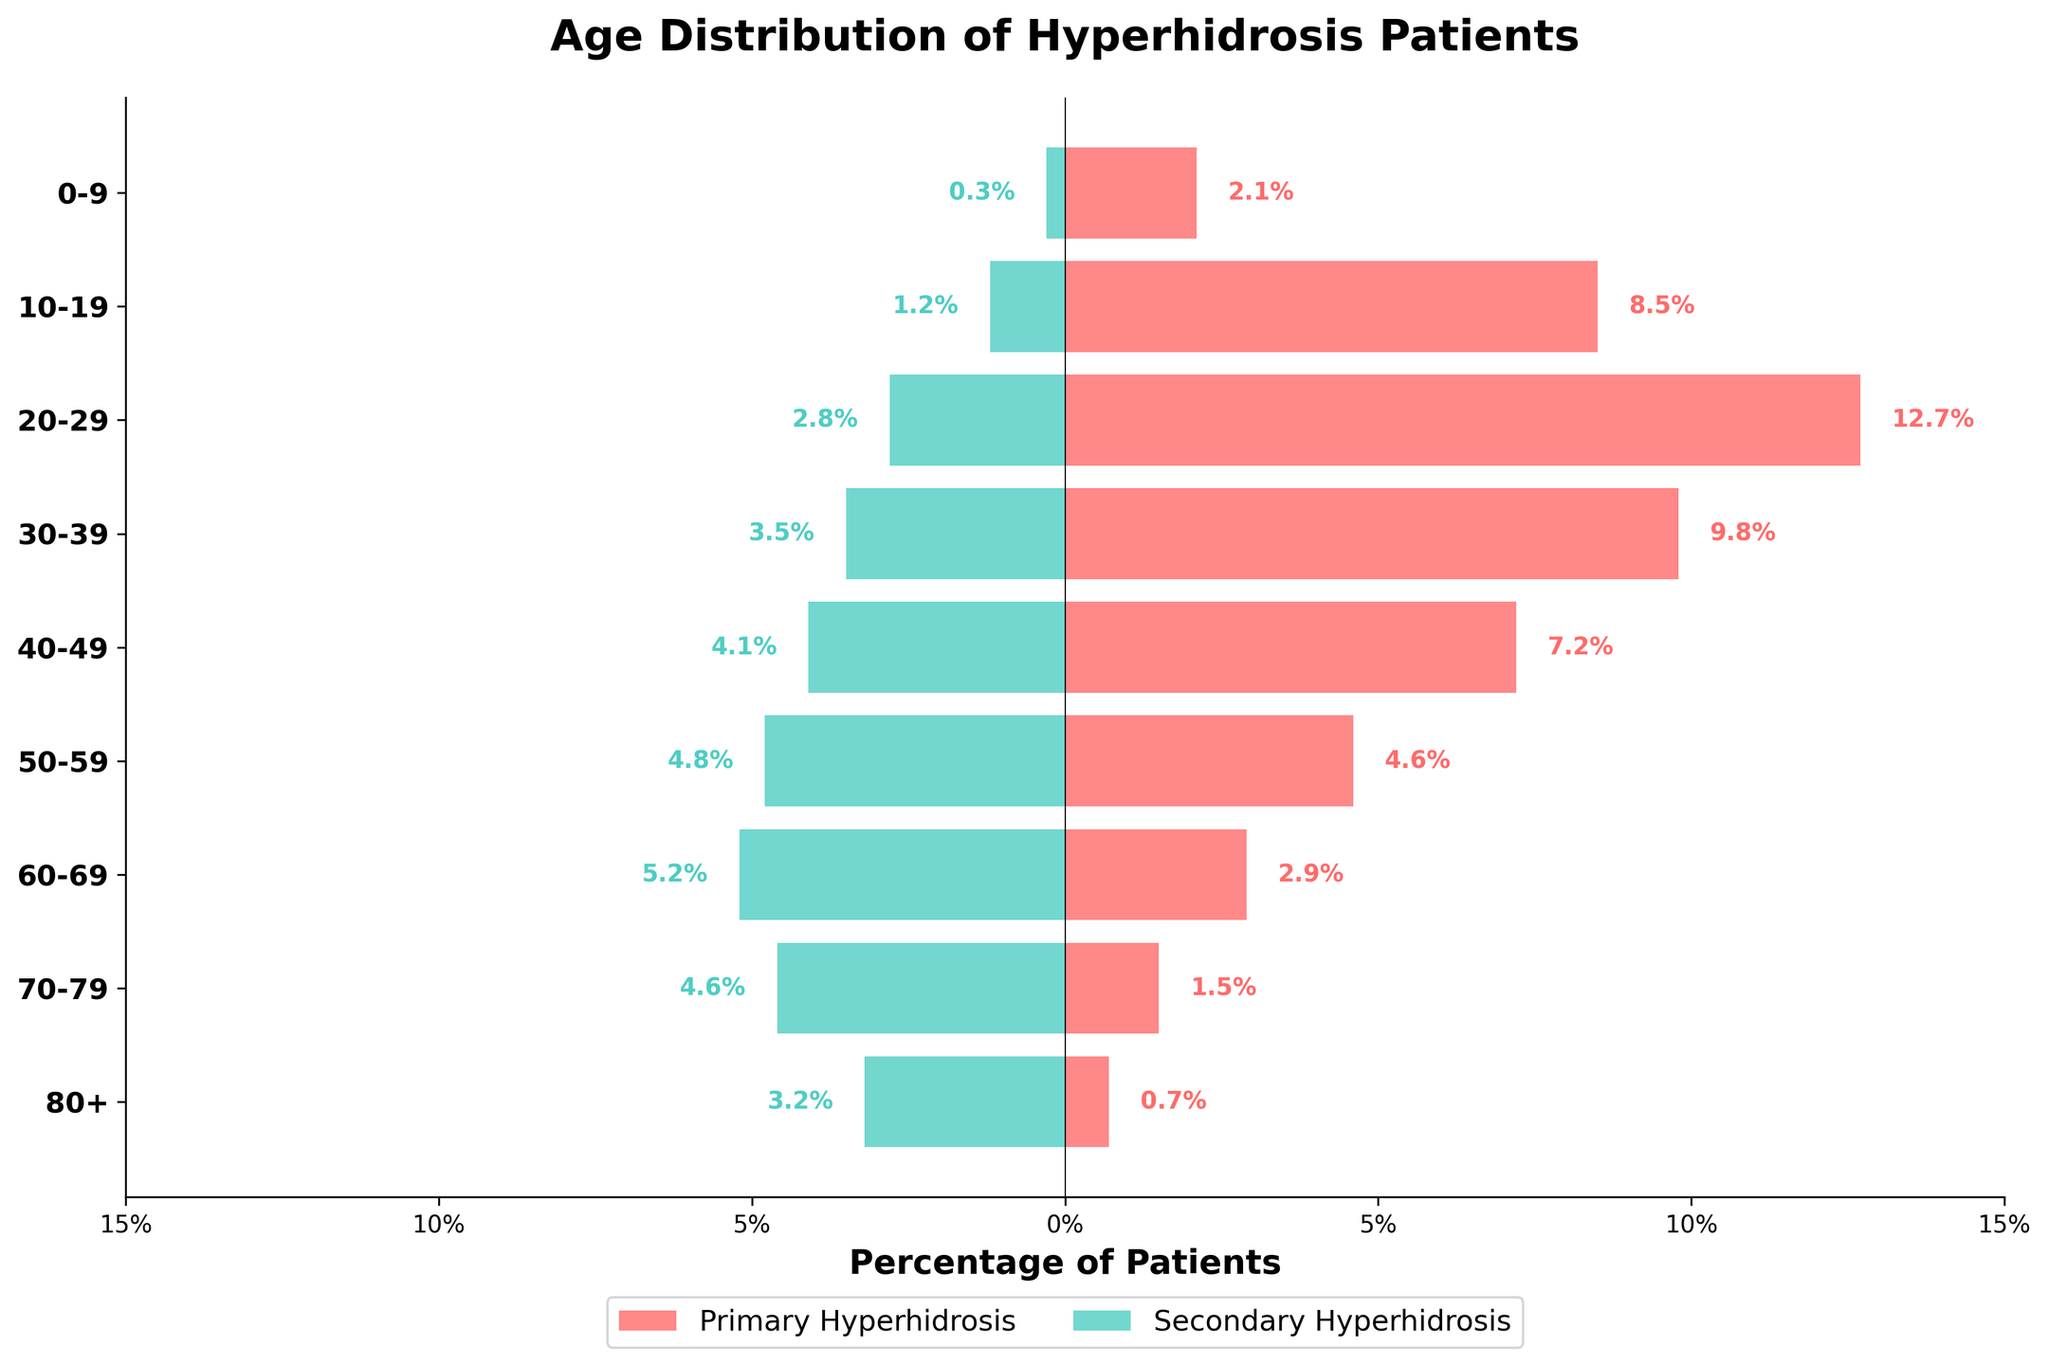What is the percentage of primary hyperhidrosis patients in the 20-29 age group? The primary hyperhidrosis percentage for the 20-29 age group is given as -12.7. The negative sign indicates that this is on the left side of the pyramid.
Answer: 12.7% Which age group has the highest percentage of secondary hyperhidrosis patients? Based on the bar lengths, the 60-69 age group has the longest bar on the right side, indicating the highest percentage of secondary hyperhidrosis patients.
Answer: 60-69 What is the total percentage of hyperhidrosis patients (primary and secondary) in the 40-49 age group? Add the percentages of primary (-7.2) and secondary (4.1) hyperhidrosis in the 40-49 age group: -7.2 + 4.1 = -3.1. In absolute terms, the total is 7.2 + 4.1 = 11.3%.
Answer: 11.3% In which age group is the gap between primary and secondary hyperhidrosis patients the smallest? The difference between the percentages of primary and secondary hyperhidrosis patients is closest in the 0-9 age group, where primary is -2.1% and secondary is 0.3%, giving a difference of 2.4%.
Answer: 0-9 Do any age groups have more secondary than primary hyperhidrosis patients? All age groups show longer red bars (primary) on the left than the green bars (secondary) on the right, indicating more primary hyperhidrosis patients in all age groups.
Answer: No Which age group has the lowest percentage of primary hyperhidrosis patients? The shortest red bar on the left represents the 80+ age group, indicating the lowest percentage of primary hyperhidrosis patients.
Answer: 80+ How many age groups have secondary hyperhidrosis percentages higher than 4%? Counting the bars on the right side that exceed 4% for secondary hyperhidrosis gives three age groups: 50-59, 60-69, and 70-79.
Answer: 3 What is the average percentage of primary hyperhidrosis patients across all age groups? Sum all percentages of primary hyperhidrosis and divide by the number of age groups: (-2.1 + -8.5 + -12.7 + -9.8 + -7.2 + -4.6 + -2.9 + -1.5 + -0.7) / 9 = -50.0 / 9 = -5.56.
Answer: 5.56% In the 30-39 age group, how does the percentage of secondary hyperhidrosis compare to the 80+ age group? The secondary hyperhidrosis percentage is 3.5% for 30-39 and 3.2% for 80+, thus higher in the 30-39 age group.
Answer: Higher 